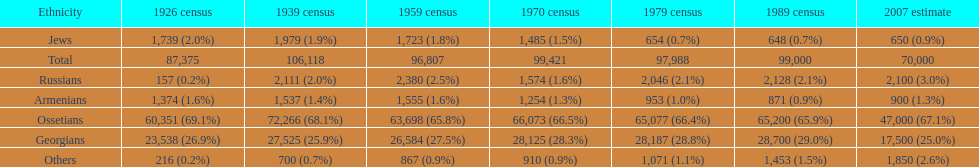What was the first census that saw a russian population of over 2,000? 1939 census. 